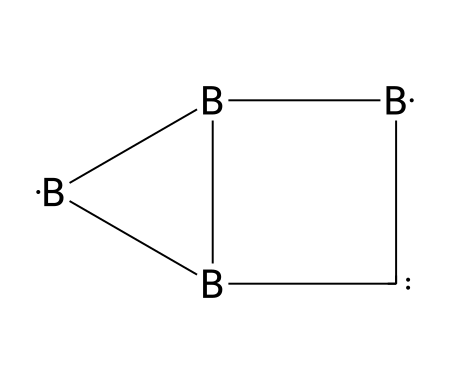how many boron atoms are in the structure? The SMILES representation contains multiple instances of boron represented by the symbol [B]. Counting these gives a total of three boron atoms.
Answer: three what type of bonds are present in the structure? The structure has a combination of boron-boron and boron-carbon bonds, as indicated by the connectivity of the atoms in the SMILES notation.
Answer: boron-boron and boron-carbon what is the overall valence of boron in this structure? Boron typically has a valence of three, and since we see three boron atoms in this structure, the overall valence remains three as they form covalent bonds.
Answer: three how many carbon atoms are in the structure? The SMILES notation reveals that there is one carbon atom represented by the symbol [C].
Answer: one what type of borane is represented by this structure? Given the arrangement of the atoms and the polyhedral nature indicated by the boron atoms, this is indicative of a boron cluster compound, more specifically a borane.
Answer: borane how does the arrangement of atoms suggest potential for radiation shielding? Boron clusters can form stable structures that can effectively absorb neutrons due to their specific geometrical configuration and density, which enhances their shielding capabilities.
Answer: absorb neutrons what is the significance of boron in radiation shielding? Boron is significant for its ability to capture neutrons, making it effective in radiation shielding applications, particularly for protecting excavated archaeological sites from neutron radiation.
Answer: capture neutrons 